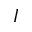<formula> <loc_0><loc_0><loc_500><loc_500>I</formula> 